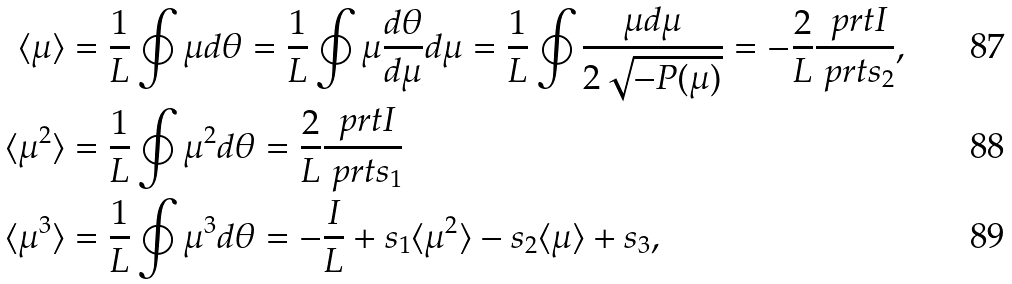<formula> <loc_0><loc_0><loc_500><loc_500>\langle \mu \rangle & = \frac { 1 } { L } \oint \mu d \theta = \frac { 1 } { L } \oint \mu \frac { d \theta } { d \mu } d \mu = \frac { 1 } { L } \oint \frac { \mu d \mu } { 2 \sqrt { - P ( \mu ) } } = - \frac { 2 } { L } \frac { \ p r t I } { \ p r t s _ { 2 } } , \\ \langle \mu ^ { 2 } \rangle & = \frac { 1 } { L } \oint \mu ^ { 2 } d \theta = \frac { 2 } { L } \frac { \ p r t I } { \ p r t s _ { 1 } } \\ \langle \mu ^ { 3 } \rangle & = \frac { 1 } { L } \oint \mu ^ { 3 } d \theta = - \frac { I } L + s _ { 1 } \langle \mu ^ { 2 } \rangle - s _ { 2 } \langle \mu \rangle + s _ { 3 } ,</formula> 